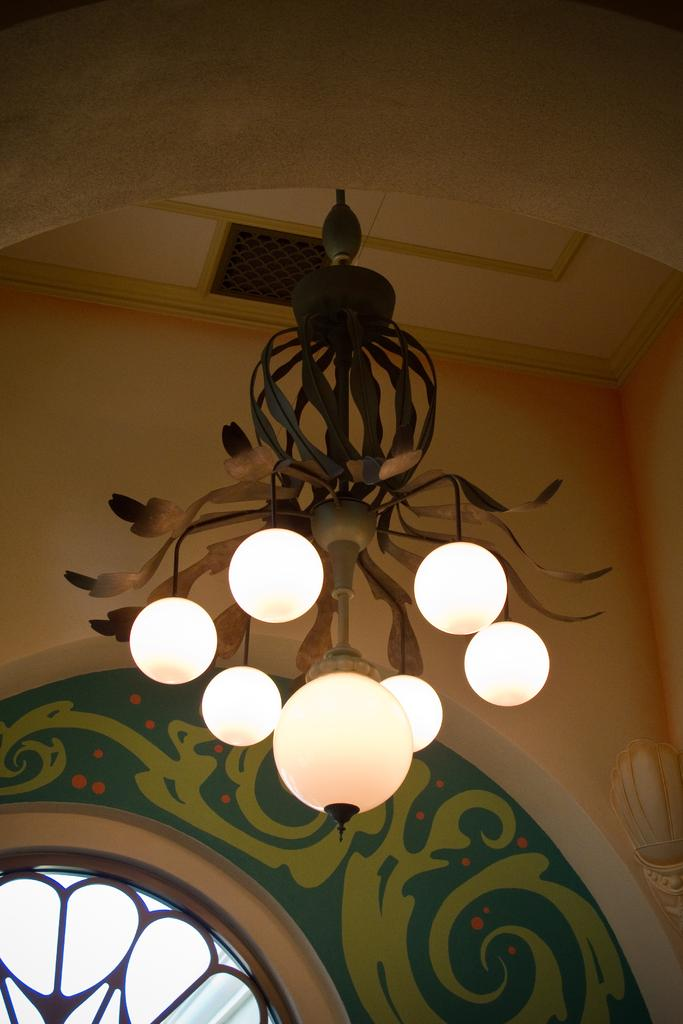What type of structure can be seen in the image? There is a wall in the image. What feature is present in the wall? There is a window in the wall. What can be seen illuminating the area in the image? There are lights in the image. Where is the shelf located in the image? There is no shelf present in the image. What type of servant is depicted in the image? There is no servant depicted in the image. 